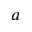<formula> <loc_0><loc_0><loc_500><loc_500>a</formula> 